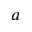<formula> <loc_0><loc_0><loc_500><loc_500>a</formula> 